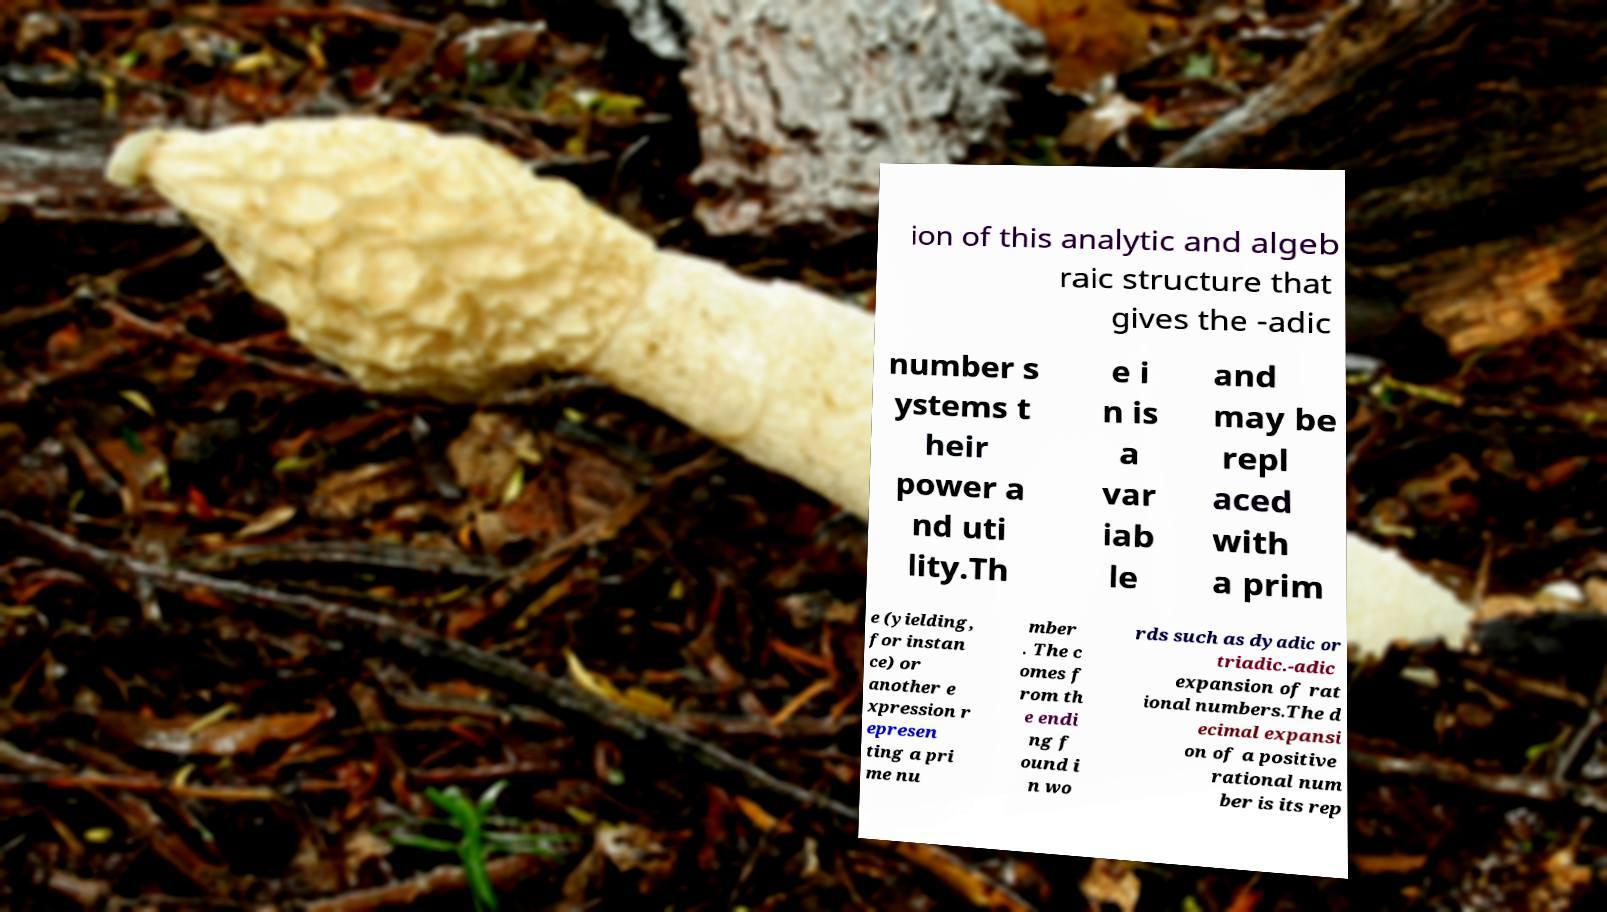What messages or text are displayed in this image? I need them in a readable, typed format. ion of this analytic and algeb raic structure that gives the -adic number s ystems t heir power a nd uti lity.Th e i n is a var iab le and may be repl aced with a prim e (yielding, for instan ce) or another e xpression r epresen ting a pri me nu mber . The c omes f rom th e endi ng f ound i n wo rds such as dyadic or triadic.-adic expansion of rat ional numbers.The d ecimal expansi on of a positive rational num ber is its rep 